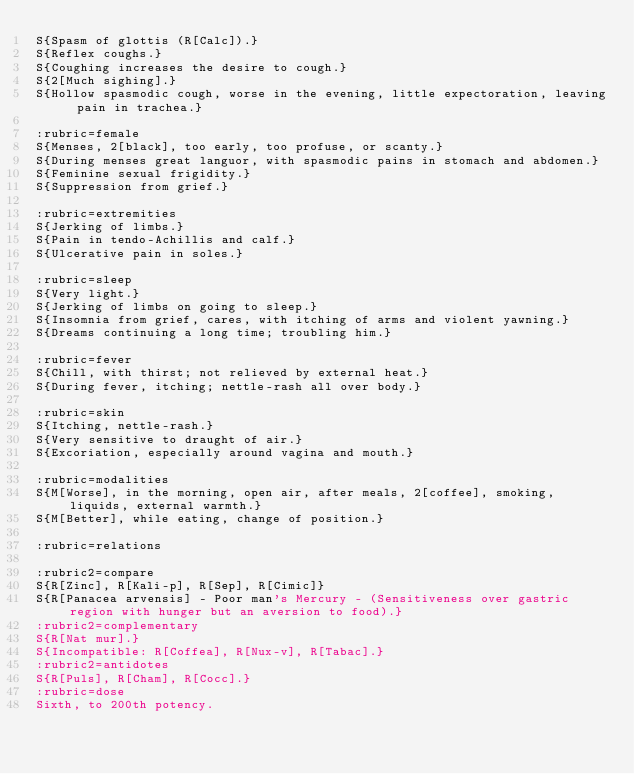Convert code to text. <code><loc_0><loc_0><loc_500><loc_500><_ObjectiveC_>S{Spasm of glottis (R[Calc]).}
S{Reflex coughs.}
S{Coughing increases the desire to cough.}
S{2[Much sighing].}
S{Hollow spasmodic cough, worse in the evening, little expectoration, leaving pain in trachea.}

:rubric=female
S{Menses, 2[black], too early, too profuse, or scanty.}
S{During menses great languor, with spasmodic pains in stomach and abdomen.}
S{Feminine sexual frigidity.}
S{Suppression from grief.}

:rubric=extremities
S{Jerking of limbs.}
S{Pain in tendo-Achillis and calf.}
S{Ulcerative pain in soles.}

:rubric=sleep
S{Very light.}
S{Jerking of limbs on going to sleep.}
S{Insomnia from grief, cares, with itching of arms and violent yawning.}
S{Dreams continuing a long time; troubling him.}

:rubric=fever
S{Chill, with thirst; not relieved by external heat.}
S{During fever, itching; nettle-rash all over body.}

:rubric=skin
S{Itching, nettle-rash.}
S{Very sensitive to draught of air.}
S{Excoriation, especially around vagina and mouth.}

:rubric=modalities
S{M[Worse], in the morning, open air, after meals, 2[coffee], smoking, liquids, external warmth.}
S{M[Better], while eating, change of position.}

:rubric=relations

:rubric2=compare
S{R[Zinc], R[Kali-p], R[Sep], R[Cimic]}
S{R[Panacea arvensis] - Poor man's Mercury - (Sensitiveness over gastric region with hunger but an aversion to food).}
:rubric2=complementary
S{R[Nat mur].}
S{Incompatible: R[Coffea], R[Nux-v], R[Tabac].}
:rubric2=antidotes
S{R[Puls], R[Cham], R[Cocc].}
:rubric=dose
Sixth, to 200th potency.</code> 